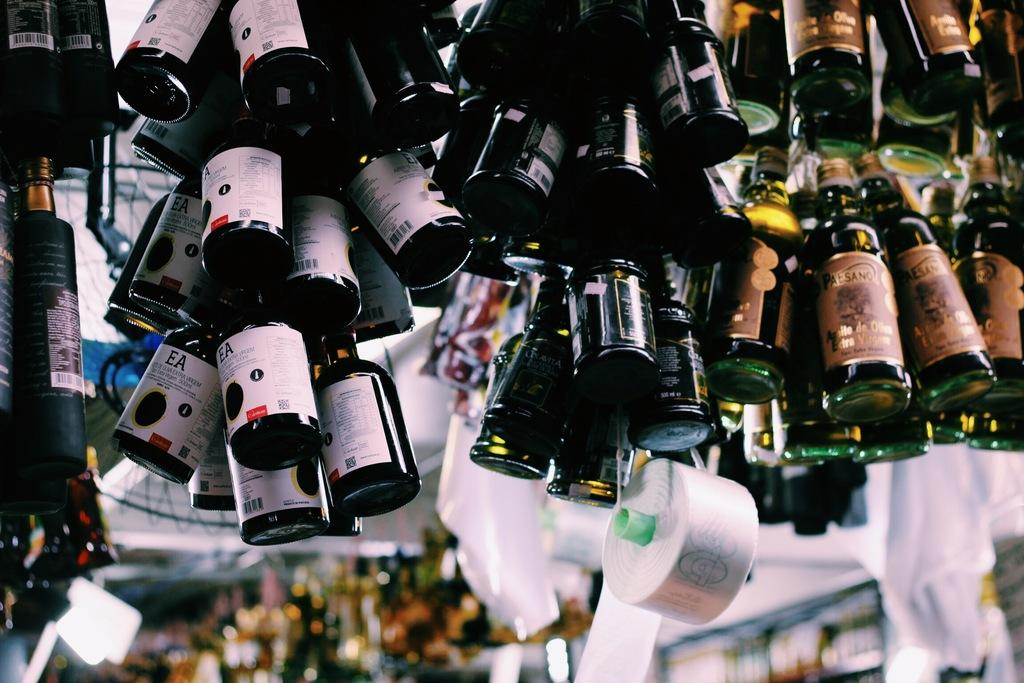What is hanging in the image? There are bottles hanging in the image. What is attached to the bottom of the hanging bottles? There is a tape at the bottom of the hanging bottles. What can be seen in the background of the image? There are stores and lights visible in the background of the image. How many brothers are laughing together in the image? There are no brothers or laughter present in the image. 